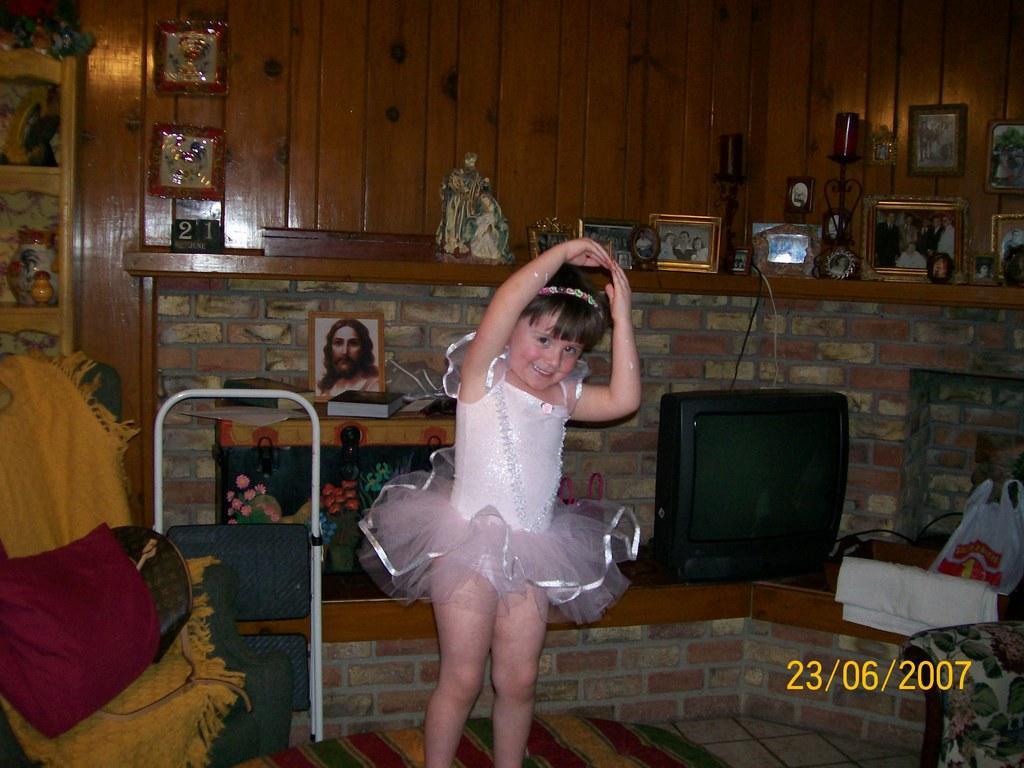Could you give a brief overview of what you see in this image? In this image we can see a girl and she is smiling. Here we can see a chair, clothes, television, plastic cover, book, frames, and objects. In the background there is a wall. 